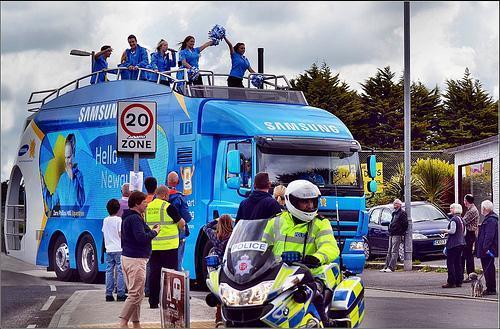How many people are standing on top of the bus?
Give a very brief answer. 5. 